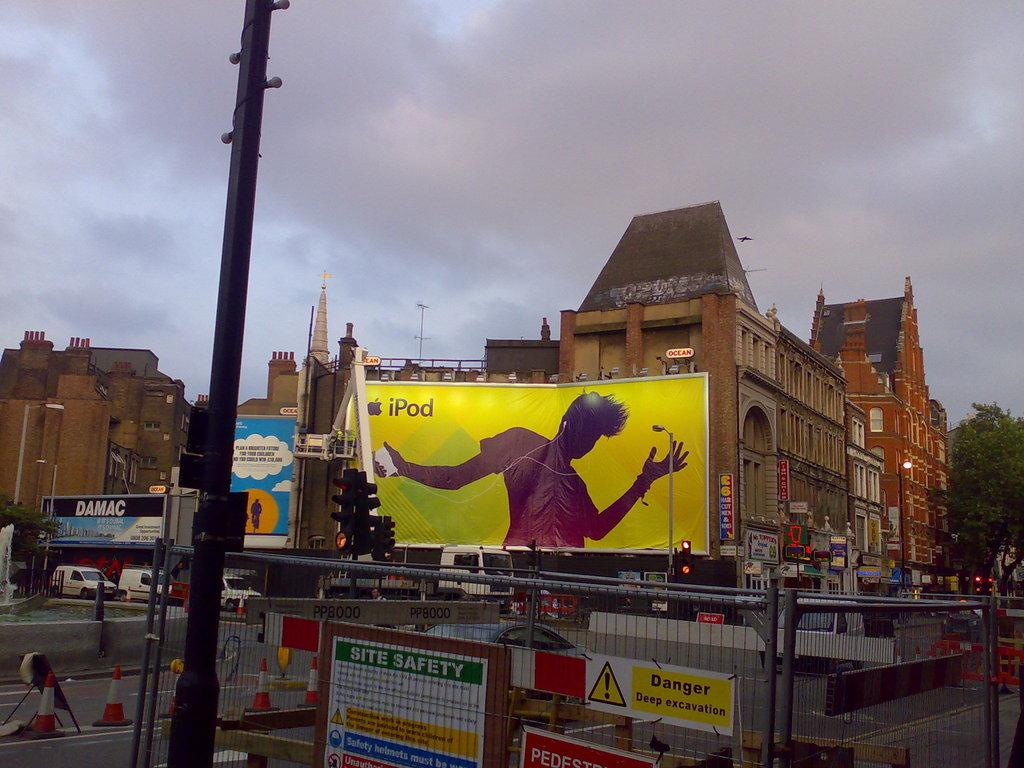<image>
Render a clear and concise summary of the photo. A large billboard ad for the iPod in a city. 